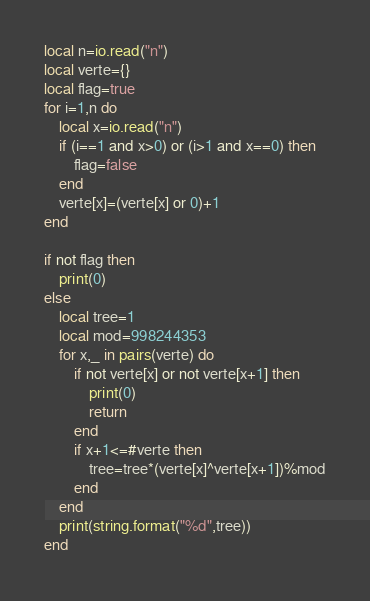<code> <loc_0><loc_0><loc_500><loc_500><_Lua_>local n=io.read("n")
local verte={}
local flag=true
for i=1,n do
    local x=io.read("n")
    if (i==1 and x>0) or (i>1 and x==0) then
        flag=false
    end
    verte[x]=(verte[x] or 0)+1
end

if not flag then
    print(0)
else
    local tree=1
    local mod=998244353
    for x,_ in pairs(verte) do
        if not verte[x] or not verte[x+1] then
            print(0)
            return
        end
        if x+1<=#verte then
            tree=tree*(verte[x]^verte[x+1])%mod
        end
    end
    print(string.format("%d",tree))
end</code> 